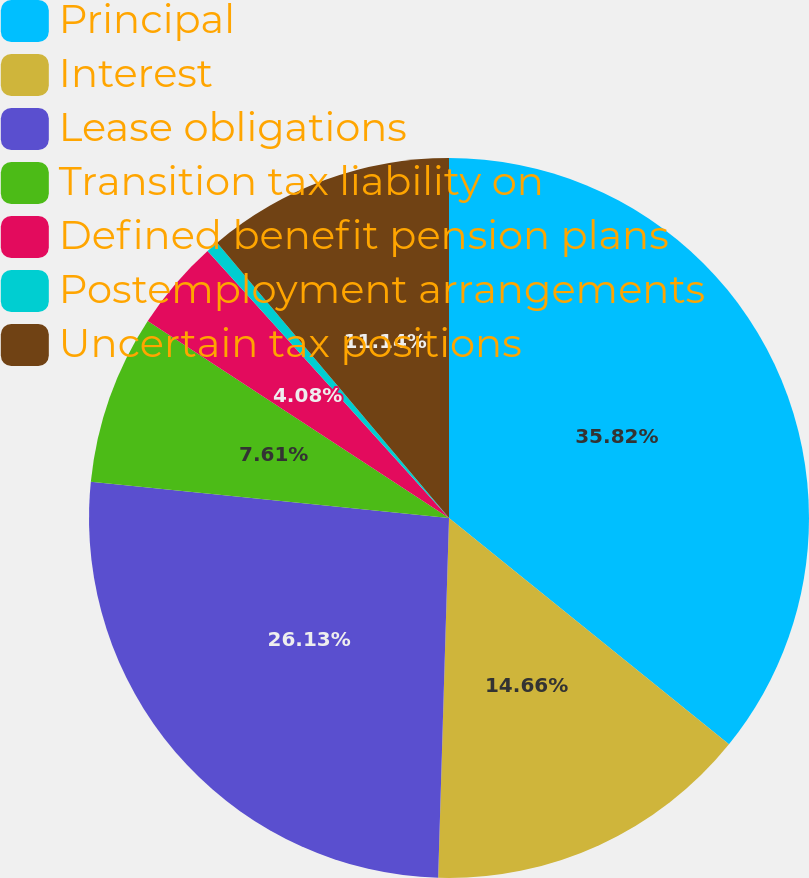Convert chart. <chart><loc_0><loc_0><loc_500><loc_500><pie_chart><fcel>Principal<fcel>Interest<fcel>Lease obligations<fcel>Transition tax liability on<fcel>Defined benefit pension plans<fcel>Postemployment arrangements<fcel>Uncertain tax positions<nl><fcel>35.82%<fcel>14.66%<fcel>26.13%<fcel>7.61%<fcel>4.08%<fcel>0.56%<fcel>11.14%<nl></chart> 